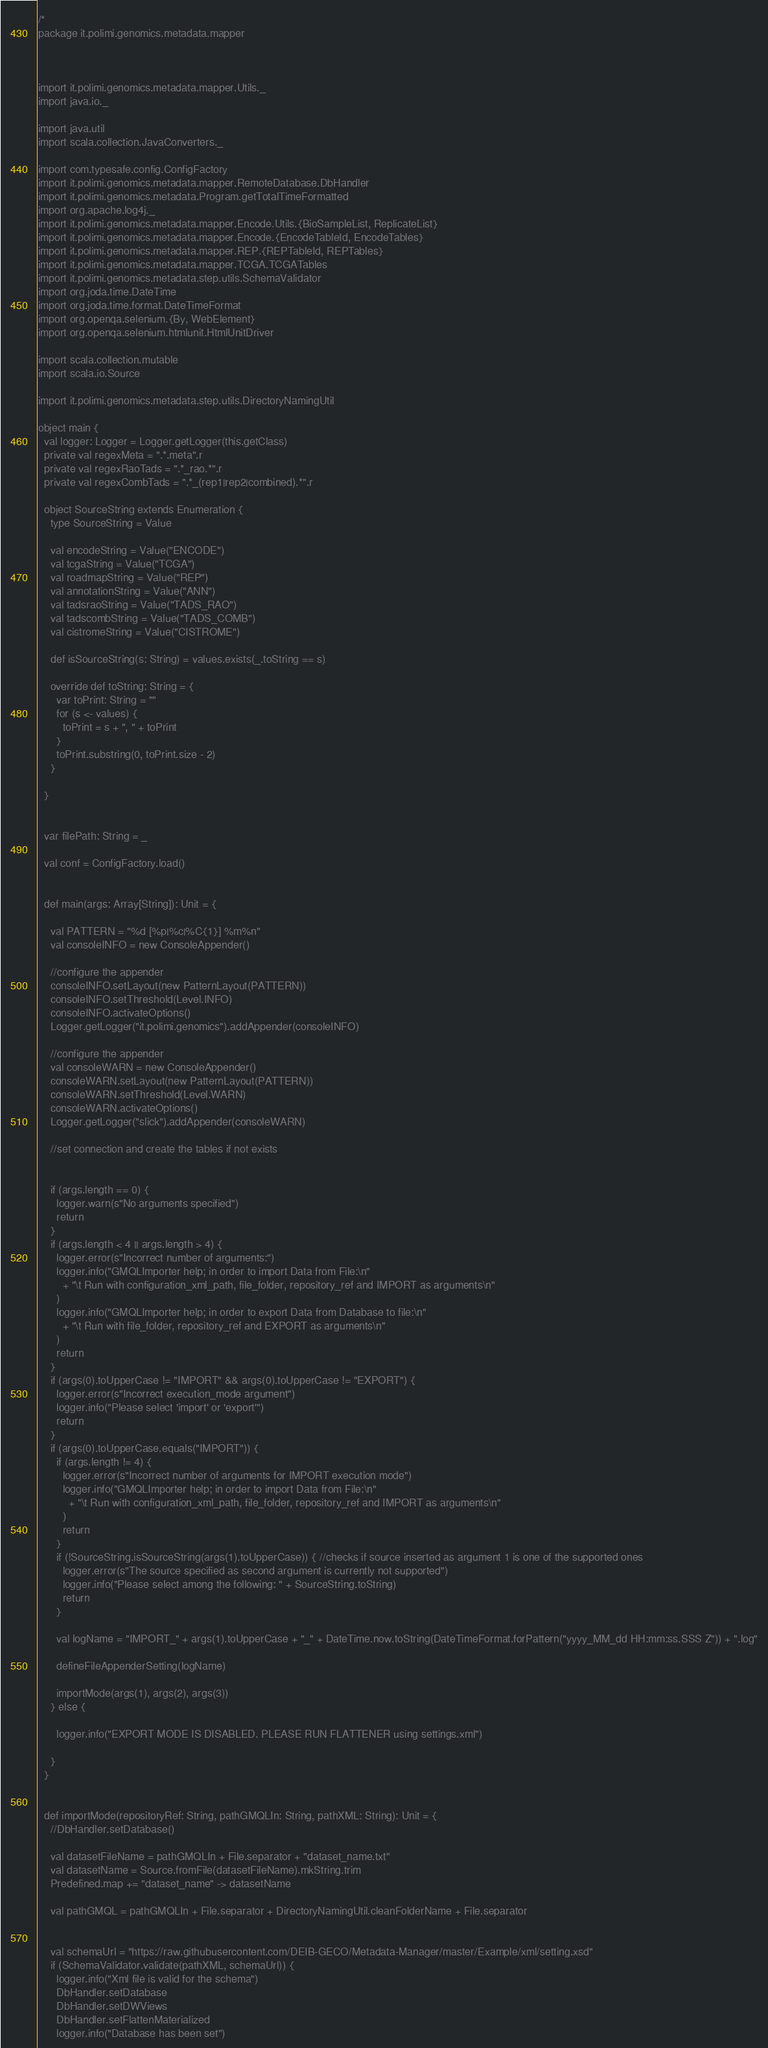<code> <loc_0><loc_0><loc_500><loc_500><_Scala_>/*
package it.polimi.genomics.metadata.mapper



import it.polimi.genomics.metadata.mapper.Utils._
import java.io._

import java.util
import scala.collection.JavaConverters._

import com.typesafe.config.ConfigFactory
import it.polimi.genomics.metadata.mapper.RemoteDatabase.DbHandler
import it.polimi.genomics.metadata.Program.getTotalTimeFormatted
import org.apache.log4j._
import it.polimi.genomics.metadata.mapper.Encode.Utils.{BioSampleList, ReplicateList}
import it.polimi.genomics.metadata.mapper.Encode.{EncodeTableId, EncodeTables}
import it.polimi.genomics.metadata.mapper.REP.{REPTableId, REPTables}
import it.polimi.genomics.metadata.mapper.TCGA.TCGATables
import it.polimi.genomics.metadata.step.utils.SchemaValidator
import org.joda.time.DateTime
import org.joda.time.format.DateTimeFormat
import org.openqa.selenium.{By, WebElement}
import org.openqa.selenium.htmlunit.HtmlUnitDriver

import scala.collection.mutable
import scala.io.Source

import it.polimi.genomics.metadata.step.utils.DirectoryNamingUtil

object main {
  val logger: Logger = Logger.getLogger(this.getClass)
  private val regexMeta = ".*.meta".r
  private val regexRaoTads = ".*_rao.*".r
  private val regexCombTads = ".*_(rep1|rep2|combined).*".r

  object SourceString extends Enumeration {
    type SourceString = Value

    val encodeString = Value("ENCODE")
    val tcgaString = Value("TCGA")
    val roadmapString = Value("REP")
    val annotationString = Value("ANN")
    val tadsraoString = Value("TADS_RAO")
    val tadscombString = Value("TADS_COMB")
    val cistromeString = Value("CISTROME")

    def isSourceString(s: String) = values.exists(_.toString == s)

    override def toString: String = {
      var toPrint: String = ""
      for (s <- values) {
        toPrint = s + ", " + toPrint
      }
      toPrint.substring(0, toPrint.size - 2)
    }

  }


  var filePath: String = _

  val conf = ConfigFactory.load()


  def main(args: Array[String]): Unit = {

    val PATTERN = "%d [%p|%c|%C{1}] %m%n"
    val consoleINFO = new ConsoleAppender()

    //configure the appender
    consoleINFO.setLayout(new PatternLayout(PATTERN))
    consoleINFO.setThreshold(Level.INFO)
    consoleINFO.activateOptions()
    Logger.getLogger("it.polimi.genomics").addAppender(consoleINFO)

    //configure the appender
    val consoleWARN = new ConsoleAppender()
    consoleWARN.setLayout(new PatternLayout(PATTERN))
    consoleWARN.setThreshold(Level.WARN)
    consoleWARN.activateOptions()
    Logger.getLogger("slick").addAppender(consoleWARN)

    //set connection and create the tables if not exists


    if (args.length == 0) {
      logger.warn(s"No arguments specified")
      return
    }
    if (args.length < 4 || args.length > 4) {
      logger.error(s"Incorrect number of arguments:")
      logger.info("GMQLImporter help; in order to import Data from File:\n"
        + "\t Run with configuration_xml_path, file_folder, repository_ref and IMPORT as arguments\n"
      )
      logger.info("GMQLImporter help; in order to export Data from Database to file:\n"
        + "\t Run with file_folder, repository_ref and EXPORT as arguments\n"
      )
      return
    }
    if (args(0).toUpperCase != "IMPORT" && args(0).toUpperCase != "EXPORT") {
      logger.error(s"Incorrect execution_mode argument")
      logger.info("Please select 'import' or 'export'")
      return
    }
    if (args(0).toUpperCase.equals("IMPORT")) {
      if (args.length != 4) {
        logger.error(s"Incorrect number of arguments for IMPORT execution mode")
        logger.info("GMQLImporter help; in order to import Data from File:\n"
          + "\t Run with configuration_xml_path, file_folder, repository_ref and IMPORT as arguments\n"
        )
        return
      }
      if (!SourceString.isSourceString(args(1).toUpperCase)) { //checks if source inserted as argument 1 is one of the supported ones
        logger.error(s"The source specified as second argument is currently not supported")
        logger.info("Please select among the following: " + SourceString.toString)
        return
      }

      val logName = "IMPORT_" + args(1).toUpperCase + "_" + DateTime.now.toString(DateTimeFormat.forPattern("yyyy_MM_dd HH:mm:ss.SSS Z")) + ".log"

      defineFileAppenderSetting(logName)

      importMode(args(1), args(2), args(3))
    } else {

      logger.info("EXPORT MODE IS DISABLED. PLEASE RUN FLATTENER using settings.xml")

    }
  }


  def importMode(repositoryRef: String, pathGMQLIn: String, pathXML: String): Unit = {
    //DbHandler.setDatabase()

    val datasetFileName = pathGMQLIn + File.separator + "dataset_name.txt"
    val datasetName = Source.fromFile(datasetFileName).mkString.trim
    Predefined.map += "dataset_name" -> datasetName

    val pathGMQL = pathGMQLIn + File.separator + DirectoryNamingUtil.cleanFolderName + File.separator


    val schemaUrl = "https://raw.githubusercontent.com/DEIB-GECO/Metadata-Manager/master/Example/xml/setting.xsd"
    if (SchemaValidator.validate(pathXML, schemaUrl)) {
      logger.info("Xml file is valid for the schema")
      DbHandler.setDatabase
      DbHandler.setDWViews
      DbHandler.setFlattenMaterialized
      logger.info("Database has been set")
</code> 